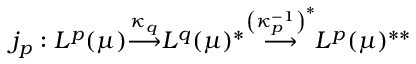<formula> <loc_0><loc_0><loc_500><loc_500>j _ { p } \colon L ^ { p } ( \mu ) { \overset { \kappa _ { q } } { \longrightarrow } } L ^ { q } ( \mu ) ^ { * } { \overset { \left ( \kappa _ { p } ^ { - 1 } \right ) ^ { * } } { \longrightarrow } } L ^ { p } ( \mu ) ^ { * * }</formula> 